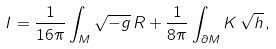<formula> <loc_0><loc_0><loc_500><loc_500>I = \frac { 1 } { 1 6 \pi } \int _ { M } \sqrt { - g } \, R + \frac { 1 } { 8 \pi } \int _ { \partial M } K \, \sqrt { h } \, ,</formula> 